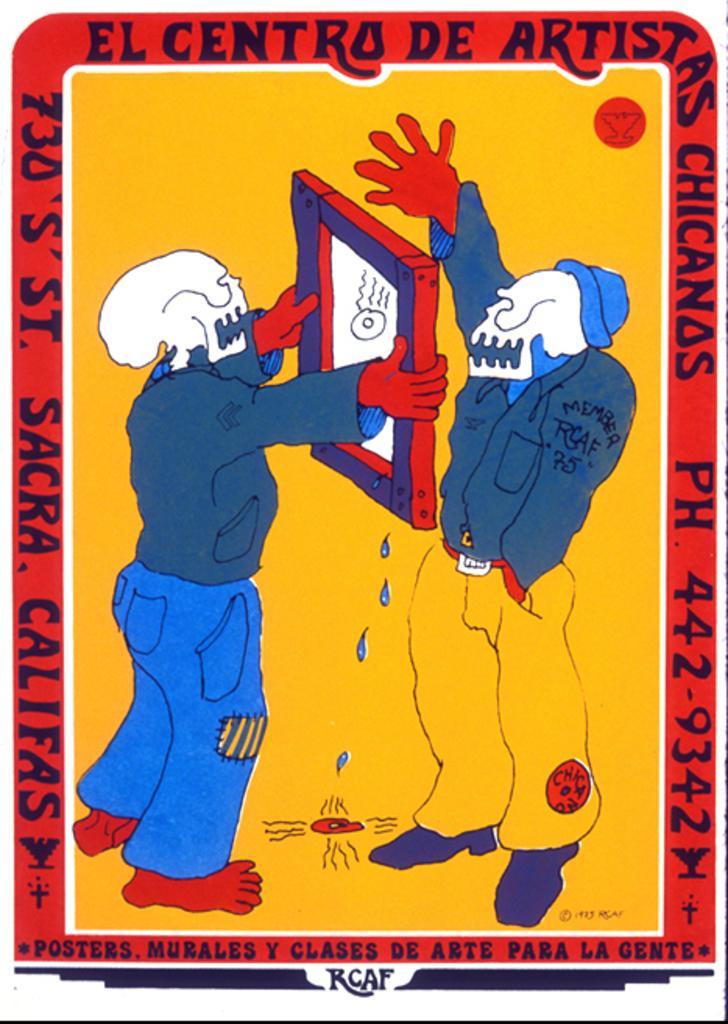Describe this image in one or two sentences. This picture contains the poster of two men standing. The man in blue pant is holding a board in his hands. In the background, it is yellow in color. We see some text written on the poster. 